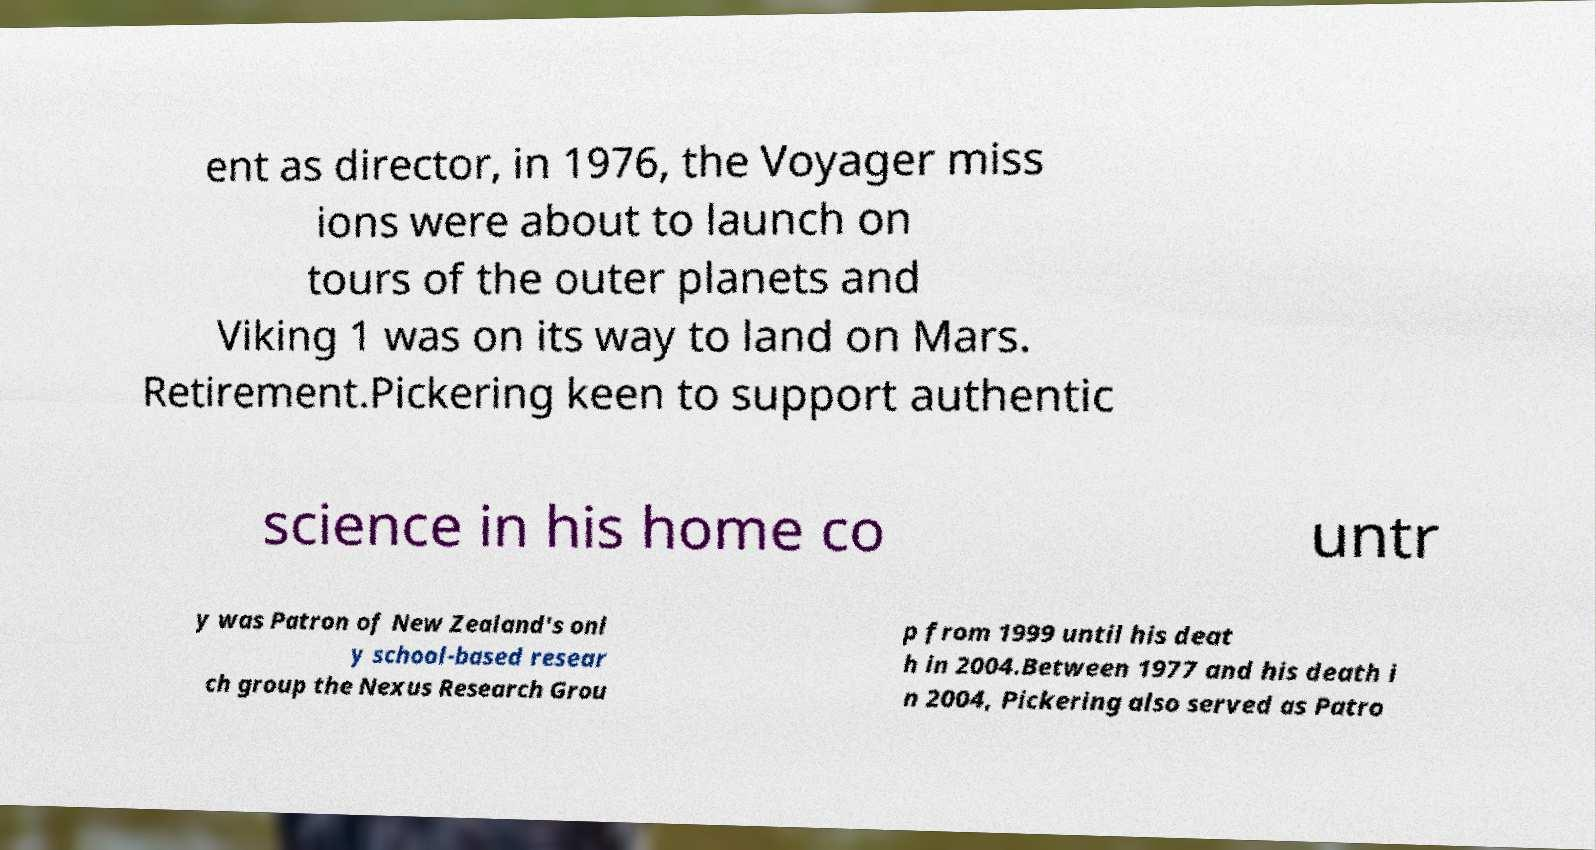Could you assist in decoding the text presented in this image and type it out clearly? ent as director, in 1976, the Voyager miss ions were about to launch on tours of the outer planets and Viking 1 was on its way to land on Mars. Retirement.Pickering keen to support authentic science in his home co untr y was Patron of New Zealand's onl y school-based resear ch group the Nexus Research Grou p from 1999 until his deat h in 2004.Between 1977 and his death i n 2004, Pickering also served as Patro 